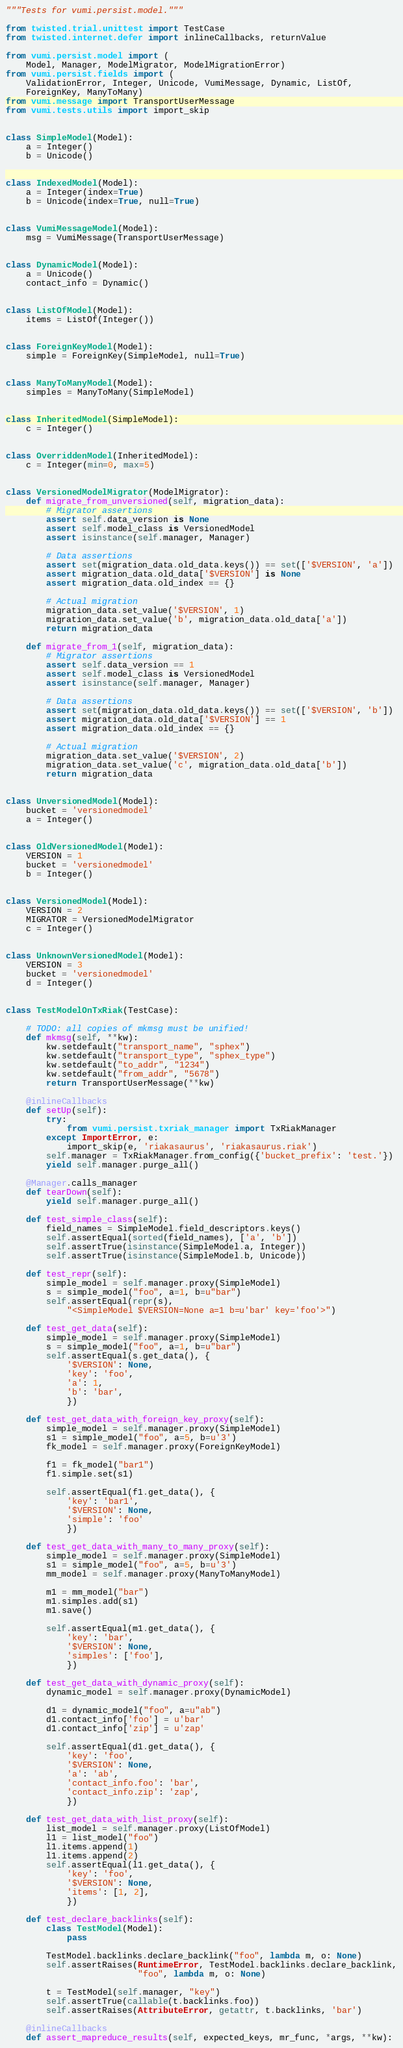Convert code to text. <code><loc_0><loc_0><loc_500><loc_500><_Python_>"""Tests for vumi.persist.model."""

from twisted.trial.unittest import TestCase
from twisted.internet.defer import inlineCallbacks, returnValue

from vumi.persist.model import (
    Model, Manager, ModelMigrator, ModelMigrationError)
from vumi.persist.fields import (
    ValidationError, Integer, Unicode, VumiMessage, Dynamic, ListOf,
    ForeignKey, ManyToMany)
from vumi.message import TransportUserMessage
from vumi.tests.utils import import_skip


class SimpleModel(Model):
    a = Integer()
    b = Unicode()


class IndexedModel(Model):
    a = Integer(index=True)
    b = Unicode(index=True, null=True)


class VumiMessageModel(Model):
    msg = VumiMessage(TransportUserMessage)


class DynamicModel(Model):
    a = Unicode()
    contact_info = Dynamic()


class ListOfModel(Model):
    items = ListOf(Integer())


class ForeignKeyModel(Model):
    simple = ForeignKey(SimpleModel, null=True)


class ManyToManyModel(Model):
    simples = ManyToMany(SimpleModel)


class InheritedModel(SimpleModel):
    c = Integer()


class OverriddenModel(InheritedModel):
    c = Integer(min=0, max=5)


class VersionedModelMigrator(ModelMigrator):
    def migrate_from_unversioned(self, migration_data):
        # Migrator assertions
        assert self.data_version is None
        assert self.model_class is VersionedModel
        assert isinstance(self.manager, Manager)

        # Data assertions
        assert set(migration_data.old_data.keys()) == set(['$VERSION', 'a'])
        assert migration_data.old_data['$VERSION'] is None
        assert migration_data.old_index == {}

        # Actual migration
        migration_data.set_value('$VERSION', 1)
        migration_data.set_value('b', migration_data.old_data['a'])
        return migration_data

    def migrate_from_1(self, migration_data):
        # Migrator assertions
        assert self.data_version == 1
        assert self.model_class is VersionedModel
        assert isinstance(self.manager, Manager)

        # Data assertions
        assert set(migration_data.old_data.keys()) == set(['$VERSION', 'b'])
        assert migration_data.old_data['$VERSION'] == 1
        assert migration_data.old_index == {}

        # Actual migration
        migration_data.set_value('$VERSION', 2)
        migration_data.set_value('c', migration_data.old_data['b'])
        return migration_data


class UnversionedModel(Model):
    bucket = 'versionedmodel'
    a = Integer()


class OldVersionedModel(Model):
    VERSION = 1
    bucket = 'versionedmodel'
    b = Integer()


class VersionedModel(Model):
    VERSION = 2
    MIGRATOR = VersionedModelMigrator
    c = Integer()


class UnknownVersionedModel(Model):
    VERSION = 3
    bucket = 'versionedmodel'
    d = Integer()


class TestModelOnTxRiak(TestCase):

    # TODO: all copies of mkmsg must be unified!
    def mkmsg(self, **kw):
        kw.setdefault("transport_name", "sphex")
        kw.setdefault("transport_type", "sphex_type")
        kw.setdefault("to_addr", "1234")
        kw.setdefault("from_addr", "5678")
        return TransportUserMessage(**kw)

    @inlineCallbacks
    def setUp(self):
        try:
            from vumi.persist.txriak_manager import TxRiakManager
        except ImportError, e:
            import_skip(e, 'riakasaurus', 'riakasaurus.riak')
        self.manager = TxRiakManager.from_config({'bucket_prefix': 'test.'})
        yield self.manager.purge_all()

    @Manager.calls_manager
    def tearDown(self):
        yield self.manager.purge_all()

    def test_simple_class(self):
        field_names = SimpleModel.field_descriptors.keys()
        self.assertEqual(sorted(field_names), ['a', 'b'])
        self.assertTrue(isinstance(SimpleModel.a, Integer))
        self.assertTrue(isinstance(SimpleModel.b, Unicode))

    def test_repr(self):
        simple_model = self.manager.proxy(SimpleModel)
        s = simple_model("foo", a=1, b=u"bar")
        self.assertEqual(repr(s),
            "<SimpleModel $VERSION=None a=1 b=u'bar' key='foo'>")

    def test_get_data(self):
        simple_model = self.manager.proxy(SimpleModel)
        s = simple_model("foo", a=1, b=u"bar")
        self.assertEqual(s.get_data(), {
            '$VERSION': None,
            'key': 'foo',
            'a': 1,
            'b': 'bar',
            })

    def test_get_data_with_foreign_key_proxy(self):
        simple_model = self.manager.proxy(SimpleModel)
        s1 = simple_model("foo", a=5, b=u'3')
        fk_model = self.manager.proxy(ForeignKeyModel)

        f1 = fk_model("bar1")
        f1.simple.set(s1)

        self.assertEqual(f1.get_data(), {
            'key': 'bar1',
            '$VERSION': None,
            'simple': 'foo'
            })

    def test_get_data_with_many_to_many_proxy(self):
        simple_model = self.manager.proxy(SimpleModel)
        s1 = simple_model("foo", a=5, b=u'3')
        mm_model = self.manager.proxy(ManyToManyModel)

        m1 = mm_model("bar")
        m1.simples.add(s1)
        m1.save()

        self.assertEqual(m1.get_data(), {
            'key': 'bar',
            '$VERSION': None,
            'simples': ['foo'],
            })

    def test_get_data_with_dynamic_proxy(self):
        dynamic_model = self.manager.proxy(DynamicModel)

        d1 = dynamic_model("foo", a=u"ab")
        d1.contact_info['foo'] = u'bar'
        d1.contact_info['zip'] = u'zap'

        self.assertEqual(d1.get_data(), {
            'key': 'foo',
            '$VERSION': None,
            'a': 'ab',
            'contact_info.foo': 'bar',
            'contact_info.zip': 'zap',
            })

    def test_get_data_with_list_proxy(self):
        list_model = self.manager.proxy(ListOfModel)
        l1 = list_model("foo")
        l1.items.append(1)
        l1.items.append(2)
        self.assertEqual(l1.get_data(), {
            'key': 'foo',
            '$VERSION': None,
            'items': [1, 2],
            })

    def test_declare_backlinks(self):
        class TestModel(Model):
            pass

        TestModel.backlinks.declare_backlink("foo", lambda m, o: None)
        self.assertRaises(RuntimeError, TestModel.backlinks.declare_backlink,
                          "foo", lambda m, o: None)

        t = TestModel(self.manager, "key")
        self.assertTrue(callable(t.backlinks.foo))
        self.assertRaises(AttributeError, getattr, t.backlinks, 'bar')

    @inlineCallbacks
    def assert_mapreduce_results(self, expected_keys, mr_func, *args, **kw):</code> 